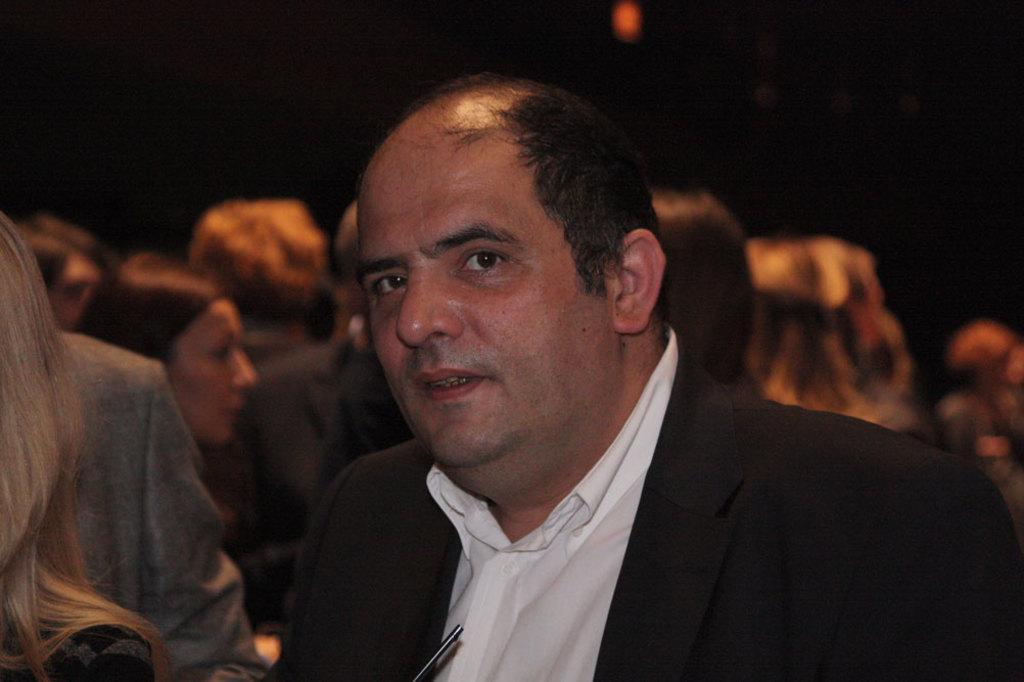Please provide a concise description of this image. In this image, in the middle, we can see a man wearing a black color suit. On the left side, we can see hair of a person. In the background, we can see a group of people and black color. 